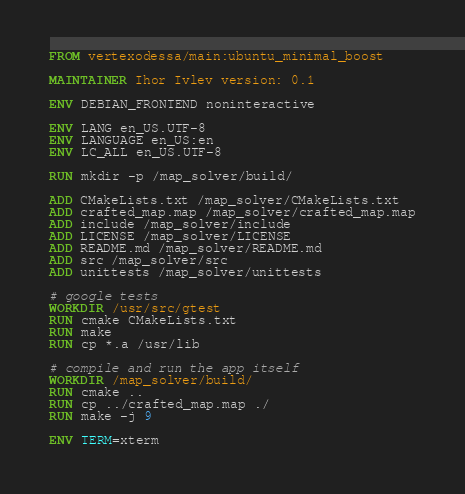<code> <loc_0><loc_0><loc_500><loc_500><_Dockerfile_>
FROM vertexodessa/main:ubuntu_minimal_boost

MAINTAINER Ihor Ivlev version: 0.1

ENV DEBIAN_FRONTEND noninteractive

ENV LANG en_US.UTF-8
ENV LANGUAGE en_US:en
ENV LC_ALL en_US.UTF-8

RUN mkdir -p /map_solver/build/

ADD CMakeLists.txt /map_solver/CMakeLists.txt
ADD crafted_map.map /map_solver/crafted_map.map
ADD include /map_solver/include
ADD LICENSE /map_solver/LICENSE
ADD README.md /map_solver/README.md
ADD src /map_solver/src
ADD unittests /map_solver/unittests

# google tests
WORKDIR /usr/src/gtest
RUN cmake CMakeLists.txt
RUN make
RUN cp *.a /usr/lib

# compile and run the app itself
WORKDIR /map_solver/build/
RUN cmake ..
RUN cp ../crafted_map.map ./
RUN make -j 9

ENV TERM=xterm
</code> 